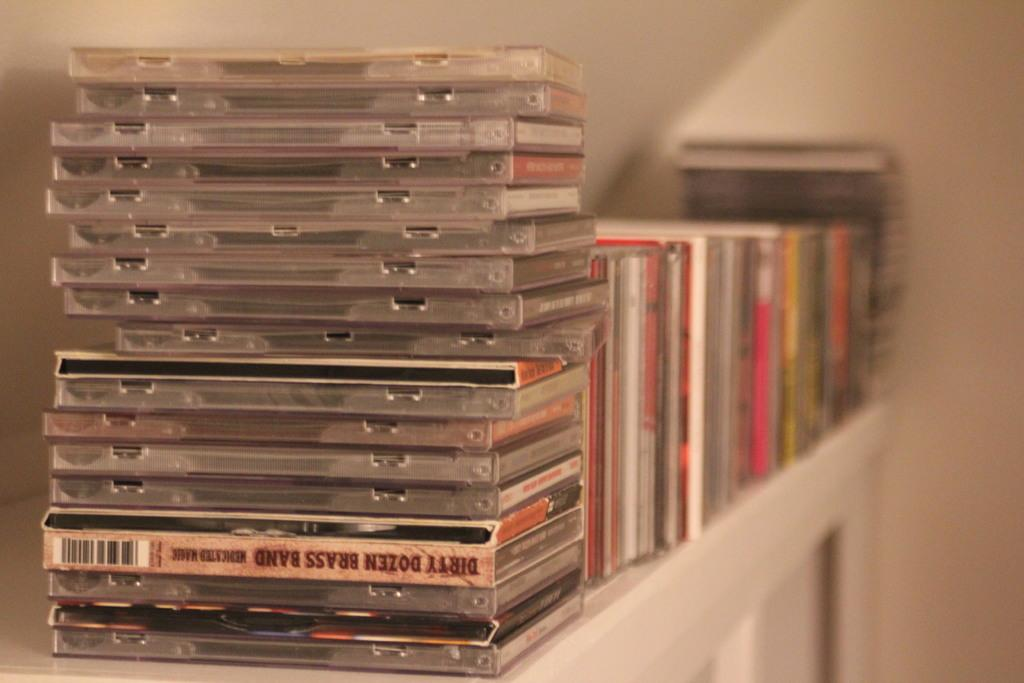<image>
Render a clear and concise summary of the photo. CD Dirty Dozen Brass Band is upside down on a stack of CDs. 